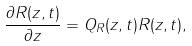<formula> <loc_0><loc_0><loc_500><loc_500>\frac { \partial R ( z , t ) } { \partial z } = Q _ { R } ( z , t ) R ( z , t ) ,</formula> 